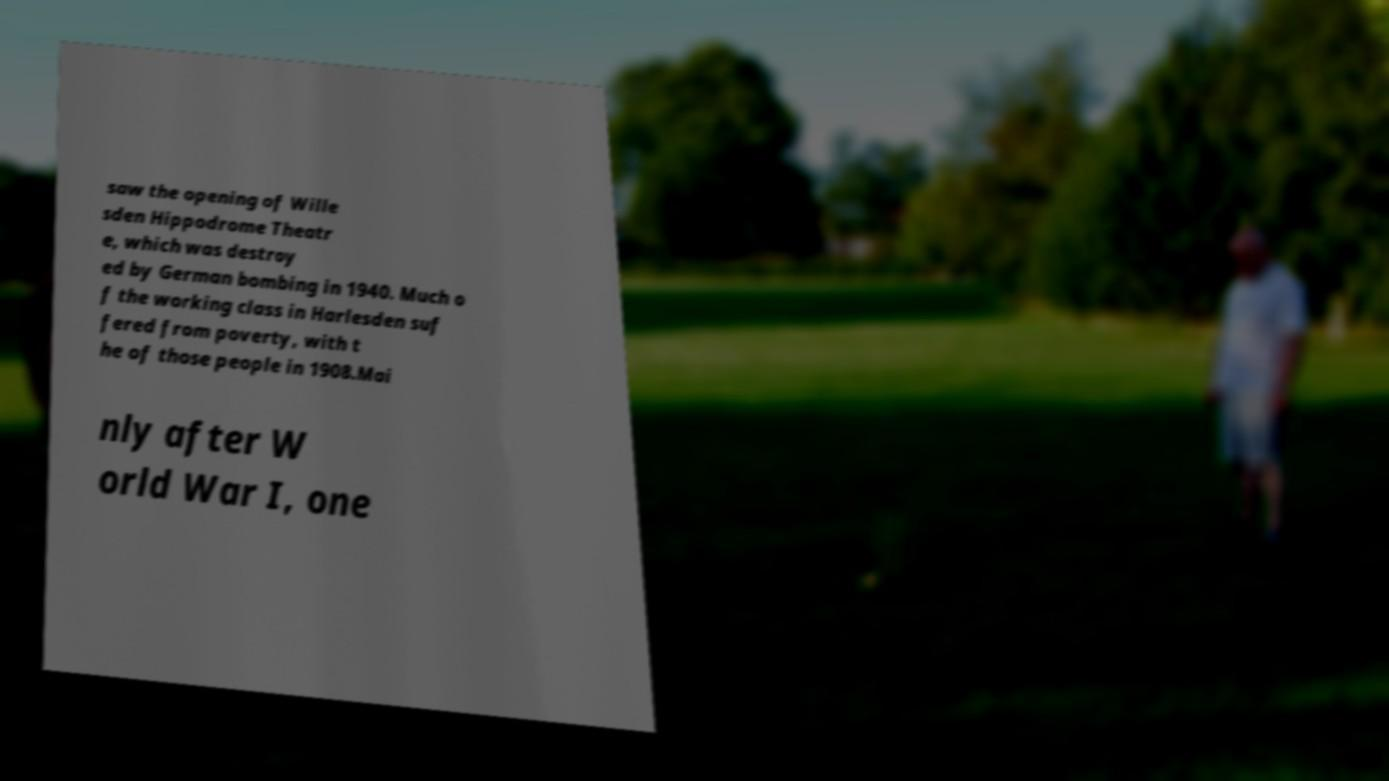Can you accurately transcribe the text from the provided image for me? saw the opening of Wille sden Hippodrome Theatr e, which was destroy ed by German bombing in 1940. Much o f the working class in Harlesden suf fered from poverty, with t he of those people in 1908.Mai nly after W orld War I, one 